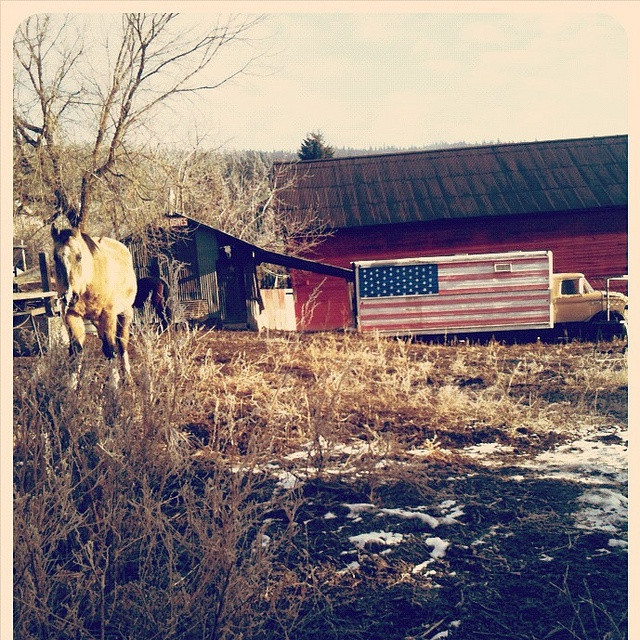Describe the objects in this image and their specific colors. I can see truck in tan, brown, navy, and darkgray tones and horse in tan, khaki, beige, gray, and black tones in this image. 